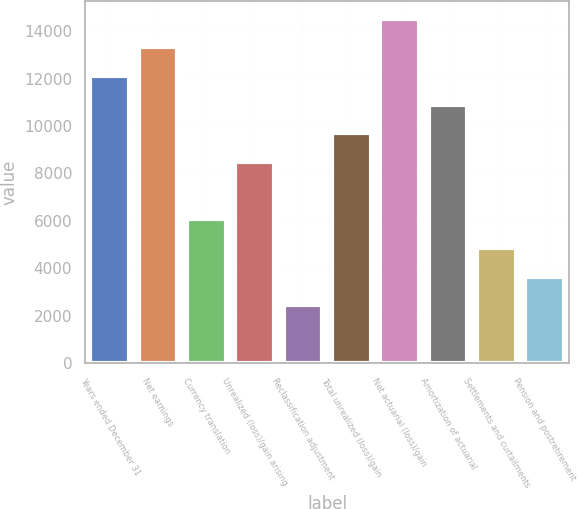Convert chart to OTSL. <chart><loc_0><loc_0><loc_500><loc_500><bar_chart><fcel>Years ended December 31<fcel>Net earnings<fcel>Currency translation<fcel>Unrealized (loss)/gain arising<fcel>Reclassification adjustment<fcel>Total unrealized (loss)/gain<fcel>Net actuarial (loss)/gain<fcel>Amortization of actuarial<fcel>Settlements and curtailments<fcel>Pension and postretirement<nl><fcel>12116<fcel>13326.7<fcel>6062.5<fcel>8483.9<fcel>2430.4<fcel>9694.6<fcel>14537.4<fcel>10905.3<fcel>4851.8<fcel>3641.1<nl></chart> 